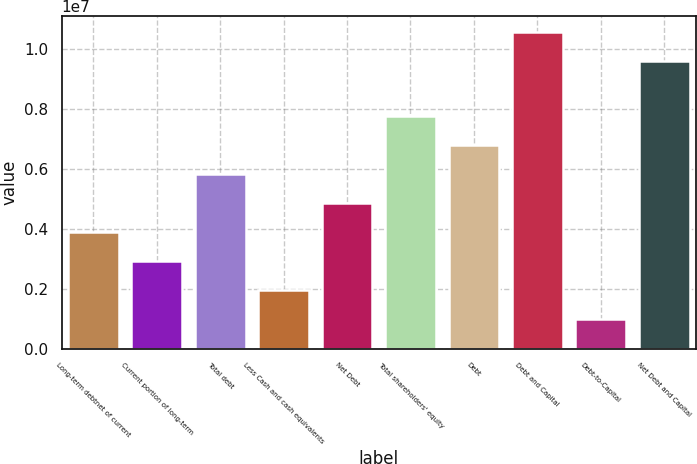<chart> <loc_0><loc_0><loc_500><loc_500><bar_chart><fcel>Long-term debtnet of current<fcel>Current portion of long-term<fcel>Total debt<fcel>Less Cash and cash equivalents<fcel>Net Debt<fcel>Total shareholders' equity<fcel>Debt<fcel>Debt and Capital<fcel>Debt-to-Capital<fcel>Net Debt and Capital<nl><fcel>3.88372e+06<fcel>2.9128e+06<fcel>5.82556e+06<fcel>1.94188e+06<fcel>4.85464e+06<fcel>7.7674e+06<fcel>6.79648e+06<fcel>1.05548e+07<fcel>970962<fcel>9.58386e+06<nl></chart> 